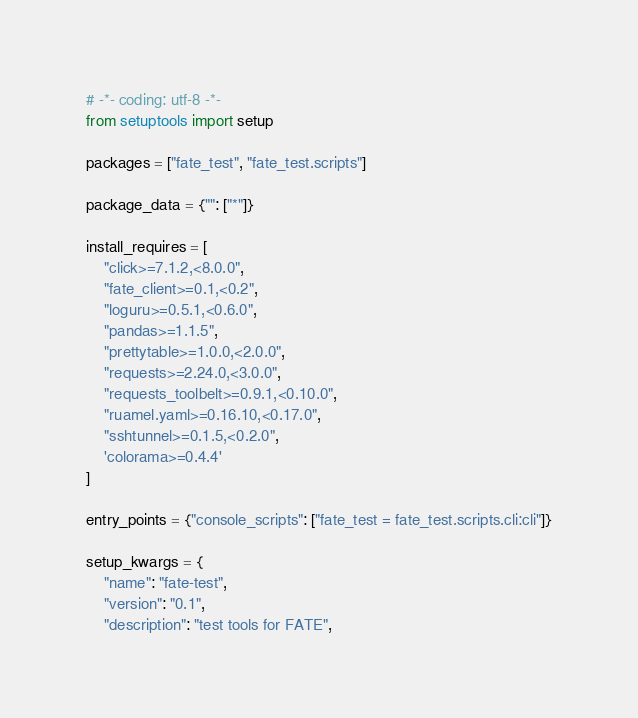<code> <loc_0><loc_0><loc_500><loc_500><_Python_># -*- coding: utf-8 -*-
from setuptools import setup

packages = ["fate_test", "fate_test.scripts"]

package_data = {"": ["*"]}

install_requires = [
    "click>=7.1.2,<8.0.0",
    "fate_client>=0.1,<0.2",
    "loguru>=0.5.1,<0.6.0",
    "pandas>=1.1.5",
    "prettytable>=1.0.0,<2.0.0",
    "requests>=2.24.0,<3.0.0",
    "requests_toolbelt>=0.9.1,<0.10.0",
    "ruamel.yaml>=0.16.10,<0.17.0",
    "sshtunnel>=0.1.5,<0.2.0",
    'colorama>=0.4.4'
]

entry_points = {"console_scripts": ["fate_test = fate_test.scripts.cli:cli"]}

setup_kwargs = {
    "name": "fate-test",
    "version": "0.1",
    "description": "test tools for FATE",</code> 